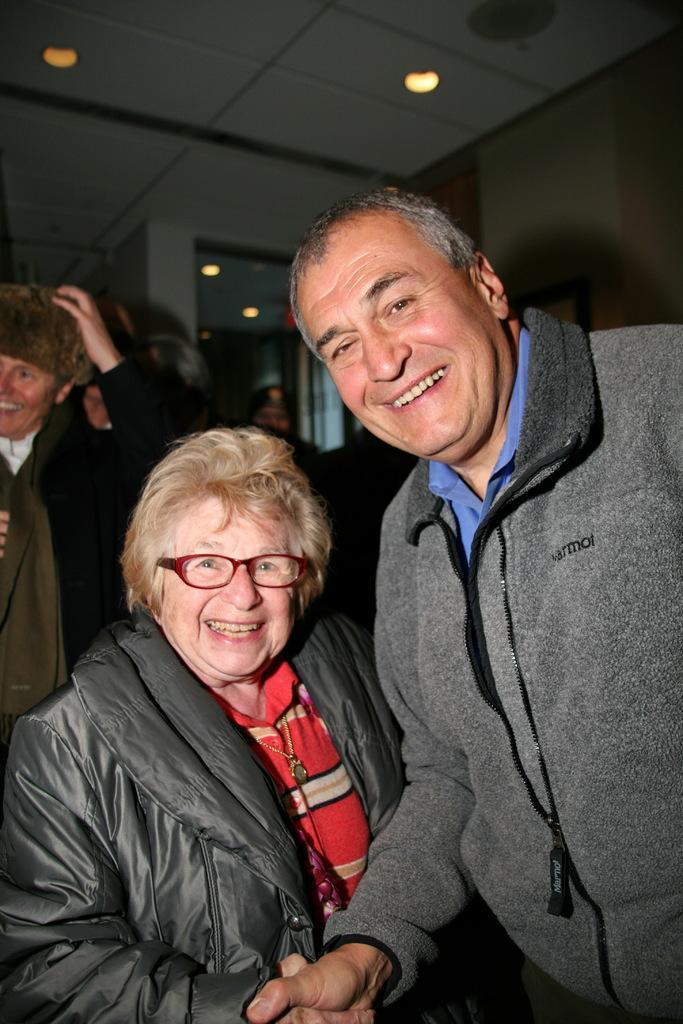Can you describe this image briefly? In this image there are two people shaking hands and posing for a picture and in the background there is a group of people. 